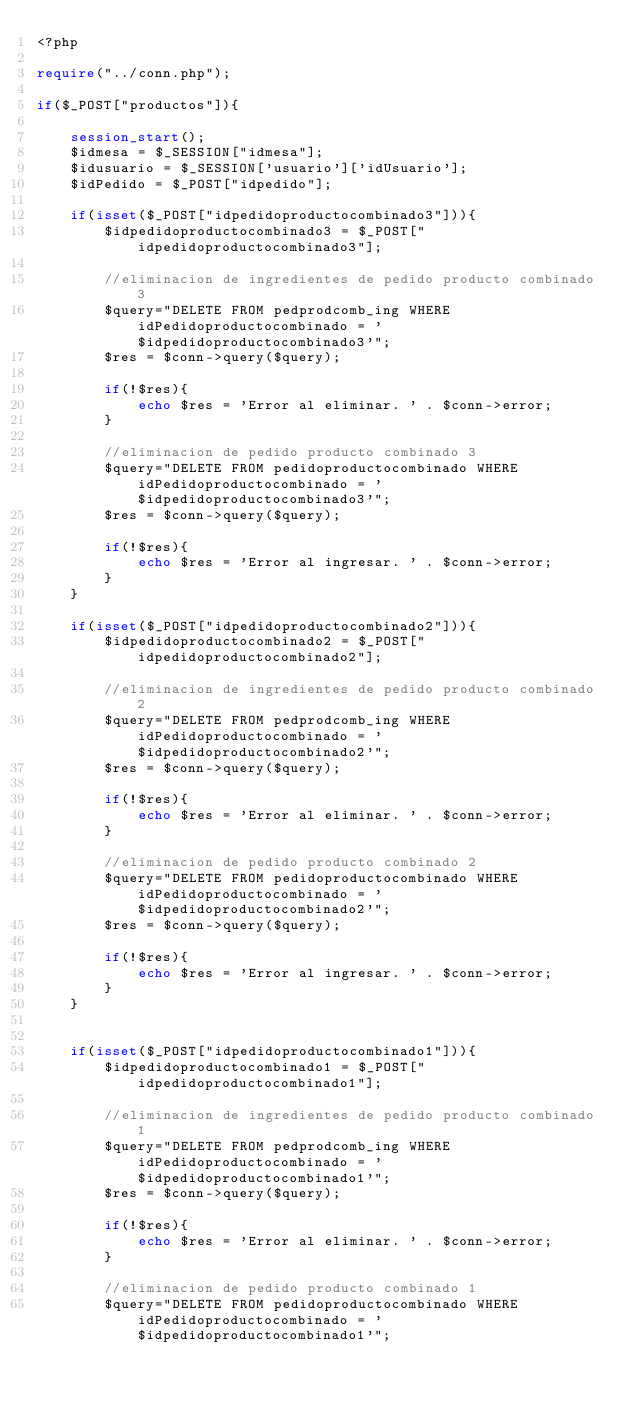Convert code to text. <code><loc_0><loc_0><loc_500><loc_500><_PHP_><?php

require("../conn.php");

if($_POST["productos"]){

    session_start();
    $idmesa = $_SESSION["idmesa"];
    $idusuario = $_SESSION['usuario']['idUsuario'];
    $idPedido = $_POST["idpedido"];

    if(isset($_POST["idpedidoproductocombinado3"])){
        $idpedidoproductocombinado3 = $_POST["idpedidoproductocombinado3"];

        //eliminacion de ingredientes de pedido producto combinado 3
        $query="DELETE FROM pedprodcomb_ing WHERE idPedidoproductocombinado = '$idpedidoproductocombinado3'";
        $res = $conn->query($query);

        if(!$res){
            echo $res = 'Error al eliminar. ' . $conn->error;
        }

        //eliminacion de pedido producto combinado 3
        $query="DELETE FROM pedidoproductocombinado WHERE idPedidoproductocombinado = '$idpedidoproductocombinado3'";
        $res = $conn->query($query);

        if(!$res){
            echo $res = 'Error al ingresar. ' . $conn->error;
        }
    }

    if(isset($_POST["idpedidoproductocombinado2"])){
        $idpedidoproductocombinado2 = $_POST["idpedidoproductocombinado2"];

        //eliminacion de ingredientes de pedido producto combinado 2
        $query="DELETE FROM pedprodcomb_ing WHERE idPedidoproductocombinado = '$idpedidoproductocombinado2'";
        $res = $conn->query($query);

        if(!$res){
            echo $res = 'Error al eliminar. ' . $conn->error;
        }

        //eliminacion de pedido producto combinado 2
        $query="DELETE FROM pedidoproductocombinado WHERE idPedidoproductocombinado = '$idpedidoproductocombinado2'";
        $res = $conn->query($query);

        if(!$res){
            echo $res = 'Error al ingresar. ' . $conn->error;
        }
    }


    if(isset($_POST["idpedidoproductocombinado1"])){
        $idpedidoproductocombinado1 = $_POST["idpedidoproductocombinado1"];

        //eliminacion de ingredientes de pedido producto combinado 1
        $query="DELETE FROM pedprodcomb_ing WHERE idPedidoproductocombinado = '$idpedidoproductocombinado1'";
        $res = $conn->query($query);

        if(!$res){
            echo $res = 'Error al eliminar. ' . $conn->error;
        }

        //eliminacion de pedido producto combinado 1
        $query="DELETE FROM pedidoproductocombinado WHERE idPedidoproductocombinado = '$idpedidoproductocombinado1'";</code> 